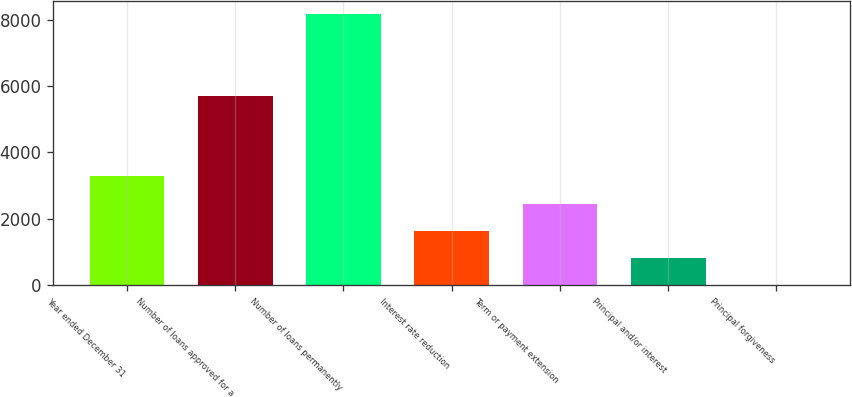<chart> <loc_0><loc_0><loc_500><loc_500><bar_chart><fcel>Year ended December 31<fcel>Number of loans approved for a<fcel>Number of loans permanently<fcel>Interest rate reduction<fcel>Term or payment extension<fcel>Principal and/or interest<fcel>Principal forgiveness<nl><fcel>3274.4<fcel>5705<fcel>8162<fcel>1645.2<fcel>2459.8<fcel>830.6<fcel>16<nl></chart> 